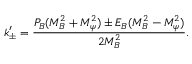<formula> <loc_0><loc_0><loc_500><loc_500>k _ { \pm } ^ { \prime } = \frac { P _ { B } ( M _ { B } ^ { 2 } + M _ { \psi } ^ { 2 } ) \pm E _ { B } ( M _ { B } ^ { 2 } - M _ { \psi } ^ { 2 } ) } { 2 M _ { B } ^ { 2 } } .</formula> 